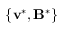<formula> <loc_0><loc_0><loc_500><loc_500>\{ v ^ { * } , B ^ { * } \}</formula> 